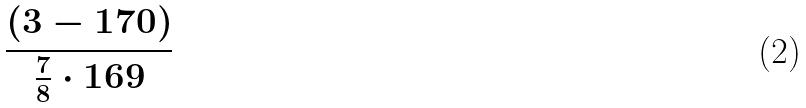Convert formula to latex. <formula><loc_0><loc_0><loc_500><loc_500>\frac { ( 3 - 1 7 0 ) } { \frac { 7 } { 8 } \cdot 1 6 9 }</formula> 